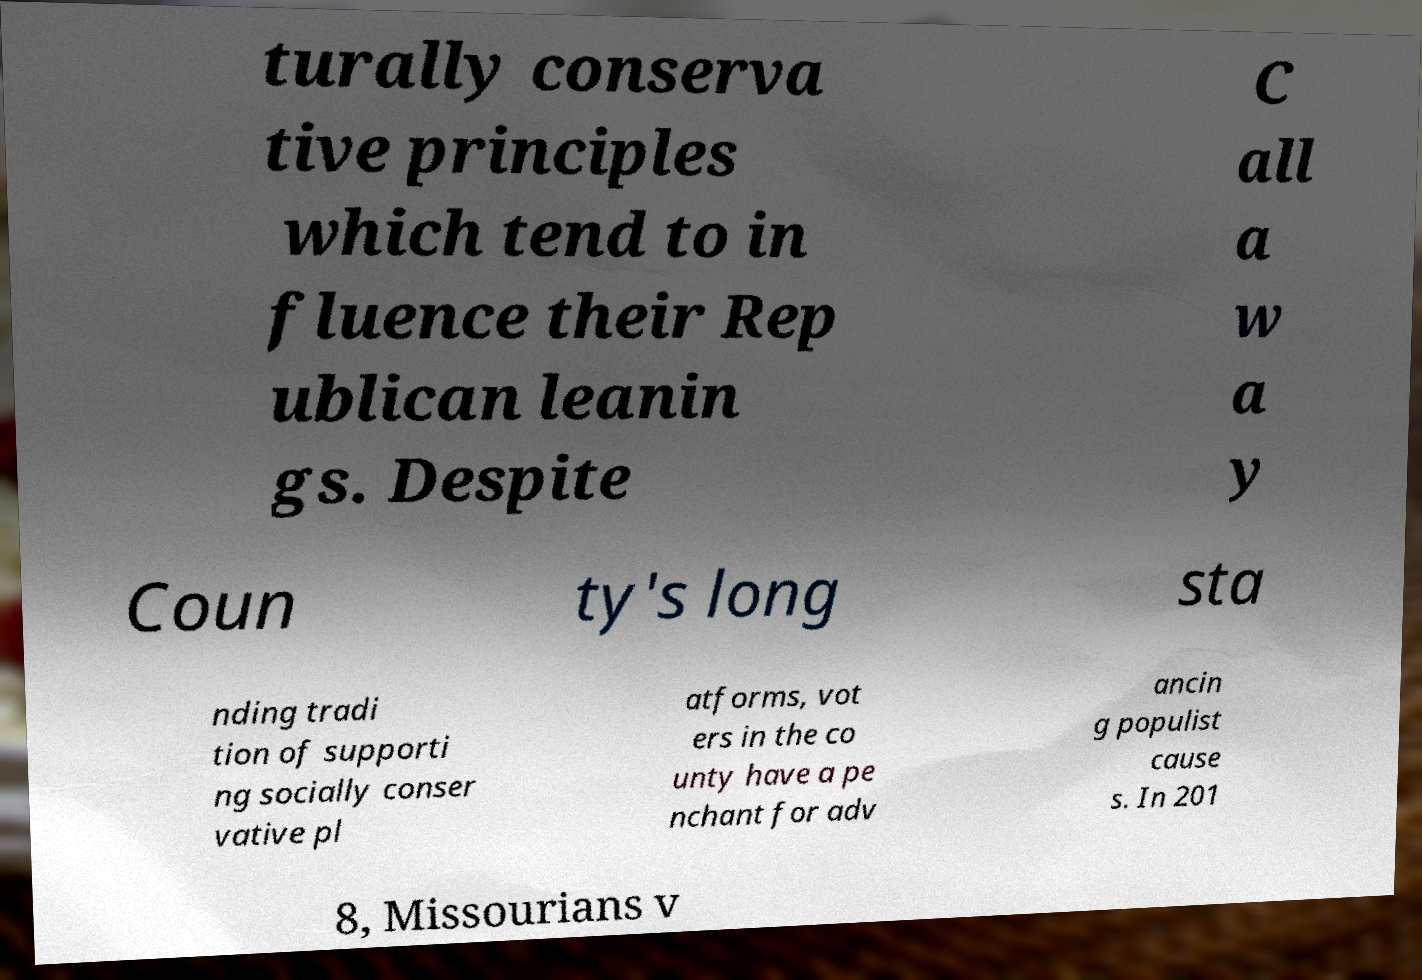Can you read and provide the text displayed in the image?This photo seems to have some interesting text. Can you extract and type it out for me? turally conserva tive principles which tend to in fluence their Rep ublican leanin gs. Despite C all a w a y Coun ty's long sta nding tradi tion of supporti ng socially conser vative pl atforms, vot ers in the co unty have a pe nchant for adv ancin g populist cause s. In 201 8, Missourians v 